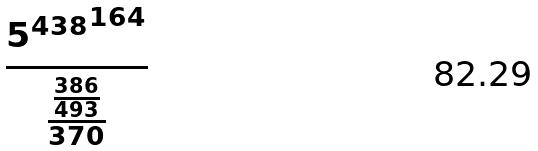<formula> <loc_0><loc_0><loc_500><loc_500>\frac { { 5 ^ { 4 3 8 } } ^ { 1 6 4 } } { \frac { \frac { 3 8 6 } { 4 9 3 } } { 3 7 0 } }</formula> 